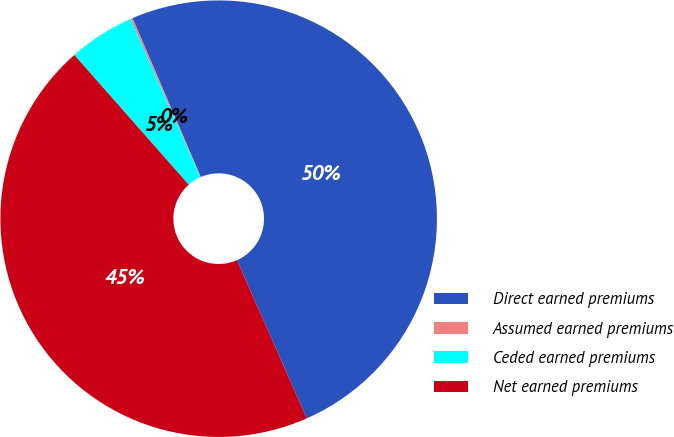<chart> <loc_0><loc_0><loc_500><loc_500><pie_chart><fcel>Direct earned premiums<fcel>Assumed earned premiums<fcel>Ceded earned premiums<fcel>Net earned premiums<nl><fcel>49.85%<fcel>0.15%<fcel>4.89%<fcel>45.11%<nl></chart> 